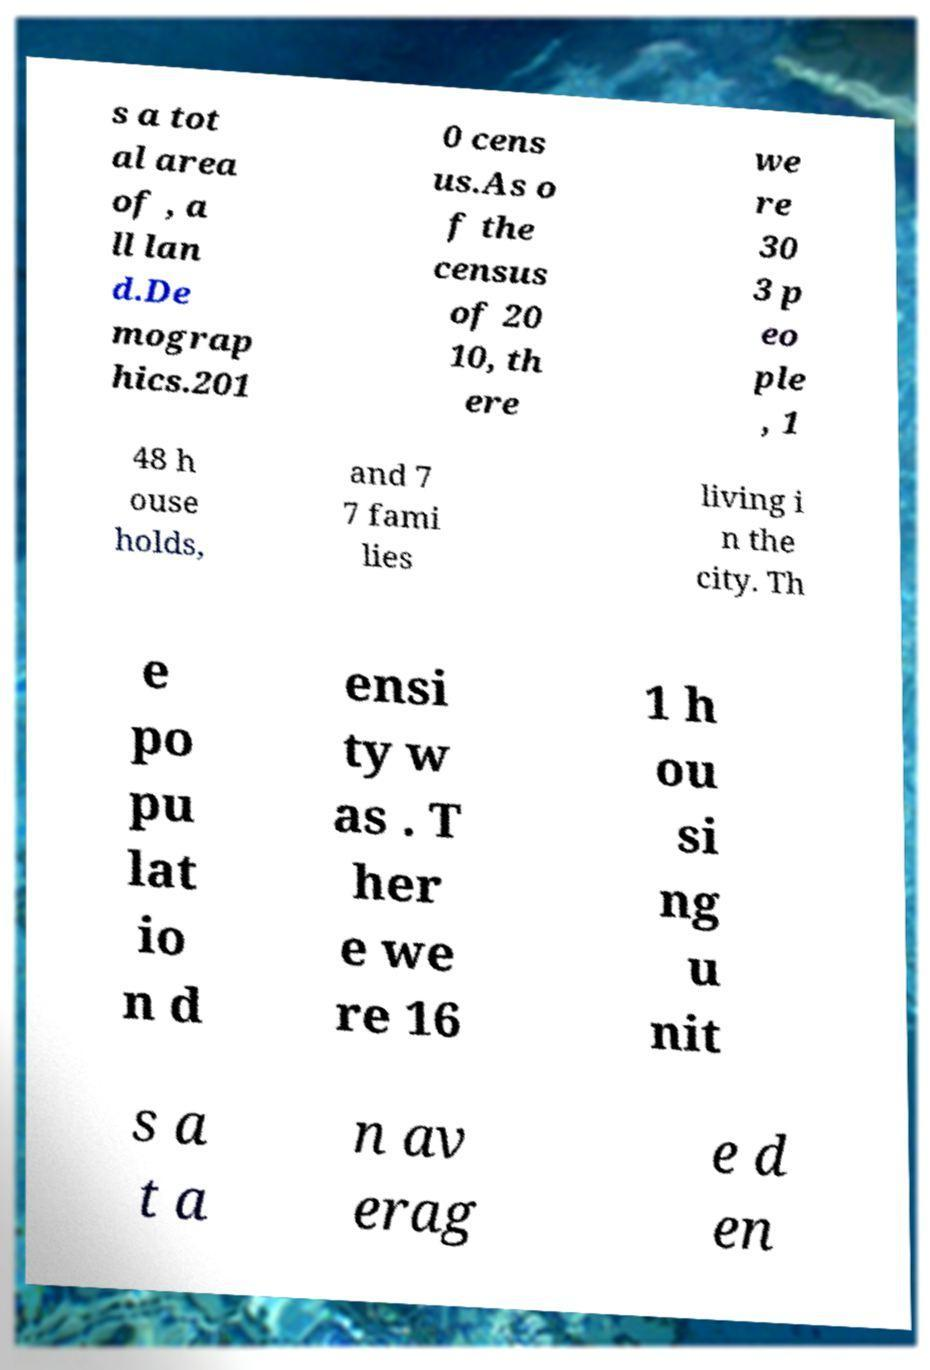Please identify and transcribe the text found in this image. s a tot al area of , a ll lan d.De mograp hics.201 0 cens us.As o f the census of 20 10, th ere we re 30 3 p eo ple , 1 48 h ouse holds, and 7 7 fami lies living i n the city. Th e po pu lat io n d ensi ty w as . T her e we re 16 1 h ou si ng u nit s a t a n av erag e d en 